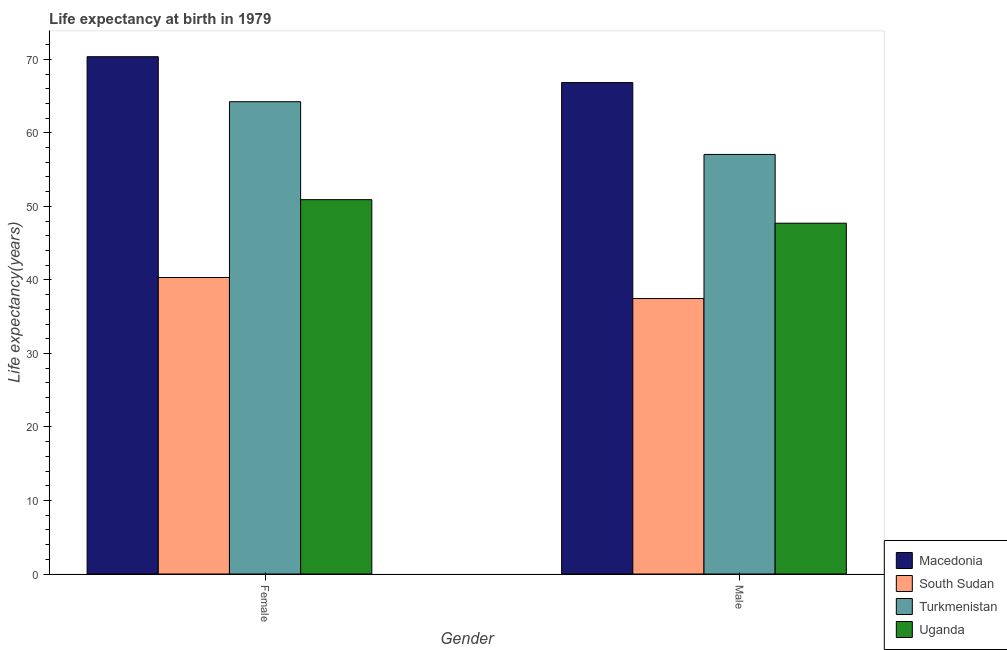How many groups of bars are there?
Your answer should be compact. 2. Are the number of bars per tick equal to the number of legend labels?
Give a very brief answer. Yes. What is the life expectancy(male) in Turkmenistan?
Give a very brief answer. 57.07. Across all countries, what is the maximum life expectancy(female)?
Your answer should be compact. 70.36. Across all countries, what is the minimum life expectancy(female)?
Your answer should be very brief. 40.33. In which country was the life expectancy(female) maximum?
Your answer should be very brief. Macedonia. In which country was the life expectancy(female) minimum?
Provide a succinct answer. South Sudan. What is the total life expectancy(female) in the graph?
Give a very brief answer. 225.84. What is the difference between the life expectancy(male) in Turkmenistan and that in Uganda?
Your response must be concise. 9.35. What is the difference between the life expectancy(female) in Macedonia and the life expectancy(male) in Uganda?
Ensure brevity in your answer.  22.65. What is the average life expectancy(female) per country?
Provide a short and direct response. 56.46. What is the difference between the life expectancy(female) and life expectancy(male) in Macedonia?
Keep it short and to the point. 3.52. What is the ratio of the life expectancy(female) in Turkmenistan to that in South Sudan?
Give a very brief answer. 1.59. In how many countries, is the life expectancy(female) greater than the average life expectancy(female) taken over all countries?
Your answer should be compact. 2. What does the 1st bar from the left in Female represents?
Provide a short and direct response. Macedonia. What does the 4th bar from the right in Female represents?
Your response must be concise. Macedonia. How many bars are there?
Your response must be concise. 8. How many countries are there in the graph?
Ensure brevity in your answer.  4. Are the values on the major ticks of Y-axis written in scientific E-notation?
Your response must be concise. No. How are the legend labels stacked?
Provide a short and direct response. Vertical. What is the title of the graph?
Make the answer very short. Life expectancy at birth in 1979. What is the label or title of the Y-axis?
Provide a short and direct response. Life expectancy(years). What is the Life expectancy(years) in Macedonia in Female?
Give a very brief answer. 70.36. What is the Life expectancy(years) in South Sudan in Female?
Your answer should be compact. 40.33. What is the Life expectancy(years) in Turkmenistan in Female?
Your answer should be compact. 64.24. What is the Life expectancy(years) in Uganda in Female?
Offer a very short reply. 50.91. What is the Life expectancy(years) of Macedonia in Male?
Keep it short and to the point. 66.84. What is the Life expectancy(years) of South Sudan in Male?
Make the answer very short. 37.47. What is the Life expectancy(years) of Turkmenistan in Male?
Offer a very short reply. 57.07. What is the Life expectancy(years) in Uganda in Male?
Ensure brevity in your answer.  47.71. Across all Gender, what is the maximum Life expectancy(years) in Macedonia?
Your answer should be compact. 70.36. Across all Gender, what is the maximum Life expectancy(years) of South Sudan?
Your response must be concise. 40.33. Across all Gender, what is the maximum Life expectancy(years) of Turkmenistan?
Keep it short and to the point. 64.24. Across all Gender, what is the maximum Life expectancy(years) of Uganda?
Provide a succinct answer. 50.91. Across all Gender, what is the minimum Life expectancy(years) in Macedonia?
Provide a short and direct response. 66.84. Across all Gender, what is the minimum Life expectancy(years) in South Sudan?
Offer a very short reply. 37.47. Across all Gender, what is the minimum Life expectancy(years) of Turkmenistan?
Provide a succinct answer. 57.07. Across all Gender, what is the minimum Life expectancy(years) in Uganda?
Give a very brief answer. 47.71. What is the total Life expectancy(years) of Macedonia in the graph?
Offer a terse response. 137.2. What is the total Life expectancy(years) in South Sudan in the graph?
Your answer should be very brief. 77.79. What is the total Life expectancy(years) in Turkmenistan in the graph?
Provide a short and direct response. 121.31. What is the total Life expectancy(years) in Uganda in the graph?
Your response must be concise. 98.63. What is the difference between the Life expectancy(years) in Macedonia in Female and that in Male?
Your response must be concise. 3.52. What is the difference between the Life expectancy(years) in South Sudan in Female and that in Male?
Keep it short and to the point. 2.86. What is the difference between the Life expectancy(years) of Turkmenistan in Female and that in Male?
Make the answer very short. 7.17. What is the difference between the Life expectancy(years) of Uganda in Female and that in Male?
Keep it short and to the point. 3.2. What is the difference between the Life expectancy(years) of Macedonia in Female and the Life expectancy(years) of South Sudan in Male?
Your answer should be very brief. 32.9. What is the difference between the Life expectancy(years) in Macedonia in Female and the Life expectancy(years) in Turkmenistan in Male?
Your answer should be compact. 13.29. What is the difference between the Life expectancy(years) in Macedonia in Female and the Life expectancy(years) in Uganda in Male?
Make the answer very short. 22.65. What is the difference between the Life expectancy(years) in South Sudan in Female and the Life expectancy(years) in Turkmenistan in Male?
Keep it short and to the point. -16.74. What is the difference between the Life expectancy(years) in South Sudan in Female and the Life expectancy(years) in Uganda in Male?
Your response must be concise. -7.39. What is the difference between the Life expectancy(years) in Turkmenistan in Female and the Life expectancy(years) in Uganda in Male?
Offer a very short reply. 16.52. What is the average Life expectancy(years) of Macedonia per Gender?
Provide a succinct answer. 68.6. What is the average Life expectancy(years) of South Sudan per Gender?
Offer a very short reply. 38.9. What is the average Life expectancy(years) of Turkmenistan per Gender?
Your response must be concise. 60.65. What is the average Life expectancy(years) of Uganda per Gender?
Provide a succinct answer. 49.31. What is the difference between the Life expectancy(years) of Macedonia and Life expectancy(years) of South Sudan in Female?
Make the answer very short. 30.03. What is the difference between the Life expectancy(years) in Macedonia and Life expectancy(years) in Turkmenistan in Female?
Provide a succinct answer. 6.12. What is the difference between the Life expectancy(years) in Macedonia and Life expectancy(years) in Uganda in Female?
Your answer should be very brief. 19.45. What is the difference between the Life expectancy(years) of South Sudan and Life expectancy(years) of Turkmenistan in Female?
Provide a short and direct response. -23.91. What is the difference between the Life expectancy(years) in South Sudan and Life expectancy(years) in Uganda in Female?
Provide a short and direct response. -10.59. What is the difference between the Life expectancy(years) in Turkmenistan and Life expectancy(years) in Uganda in Female?
Keep it short and to the point. 13.32. What is the difference between the Life expectancy(years) of Macedonia and Life expectancy(years) of South Sudan in Male?
Ensure brevity in your answer.  29.38. What is the difference between the Life expectancy(years) of Macedonia and Life expectancy(years) of Turkmenistan in Male?
Offer a terse response. 9.77. What is the difference between the Life expectancy(years) in Macedonia and Life expectancy(years) in Uganda in Male?
Your answer should be very brief. 19.13. What is the difference between the Life expectancy(years) of South Sudan and Life expectancy(years) of Turkmenistan in Male?
Offer a terse response. -19.6. What is the difference between the Life expectancy(years) of South Sudan and Life expectancy(years) of Uganda in Male?
Provide a succinct answer. -10.25. What is the difference between the Life expectancy(years) of Turkmenistan and Life expectancy(years) of Uganda in Male?
Your answer should be compact. 9.35. What is the ratio of the Life expectancy(years) in Macedonia in Female to that in Male?
Offer a terse response. 1.05. What is the ratio of the Life expectancy(years) in South Sudan in Female to that in Male?
Offer a terse response. 1.08. What is the ratio of the Life expectancy(years) of Turkmenistan in Female to that in Male?
Your response must be concise. 1.13. What is the ratio of the Life expectancy(years) in Uganda in Female to that in Male?
Ensure brevity in your answer.  1.07. What is the difference between the highest and the second highest Life expectancy(years) of Macedonia?
Your answer should be very brief. 3.52. What is the difference between the highest and the second highest Life expectancy(years) of South Sudan?
Offer a terse response. 2.86. What is the difference between the highest and the second highest Life expectancy(years) of Turkmenistan?
Offer a terse response. 7.17. What is the difference between the highest and the second highest Life expectancy(years) of Uganda?
Ensure brevity in your answer.  3.2. What is the difference between the highest and the lowest Life expectancy(years) in Macedonia?
Give a very brief answer. 3.52. What is the difference between the highest and the lowest Life expectancy(years) of South Sudan?
Your answer should be very brief. 2.86. What is the difference between the highest and the lowest Life expectancy(years) in Turkmenistan?
Offer a terse response. 7.17. What is the difference between the highest and the lowest Life expectancy(years) of Uganda?
Your response must be concise. 3.2. 